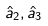<formula> <loc_0><loc_0><loc_500><loc_500>\hat { a } _ { 2 } , \hat { a } _ { 3 }</formula> 